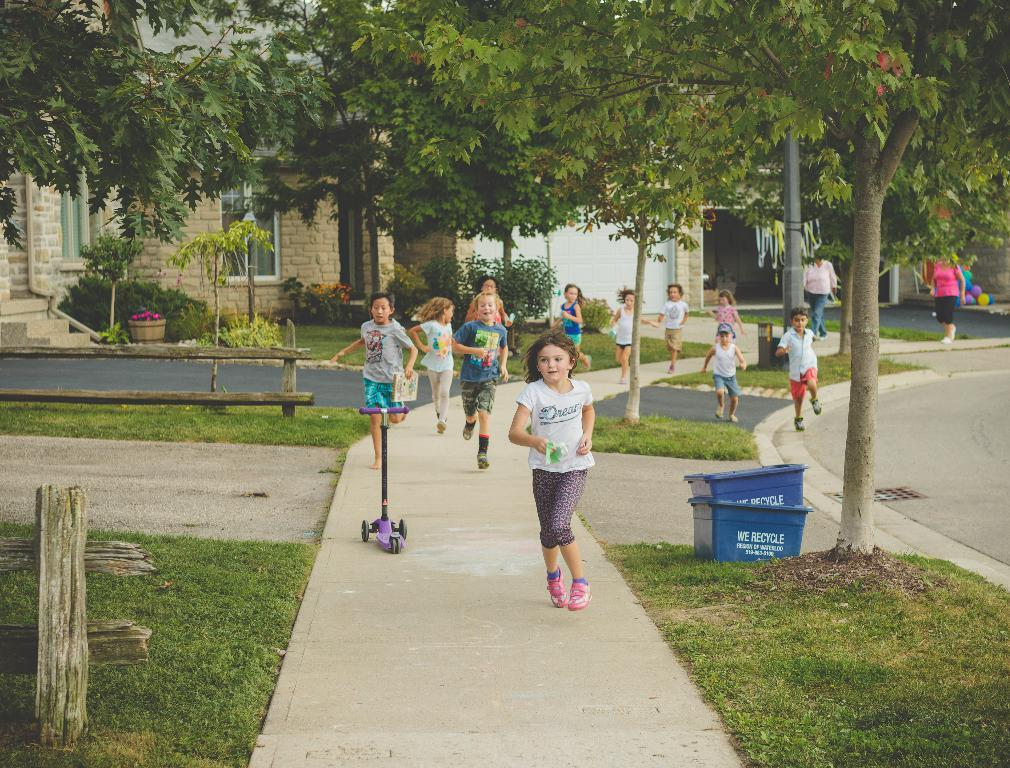What are the people in the image doing? The people in the image are running. Where are the people running in relation to the road? The people are running near a road. What type of vegetation can be seen in the image? There are trees, plants, and grass visible in the image. What type of structures can be seen in the image? There are houses in the image. What type of insurance policy do the trees in the image have? There is no information about insurance policies for the trees in the image, as they are not relevant to the image's content. 